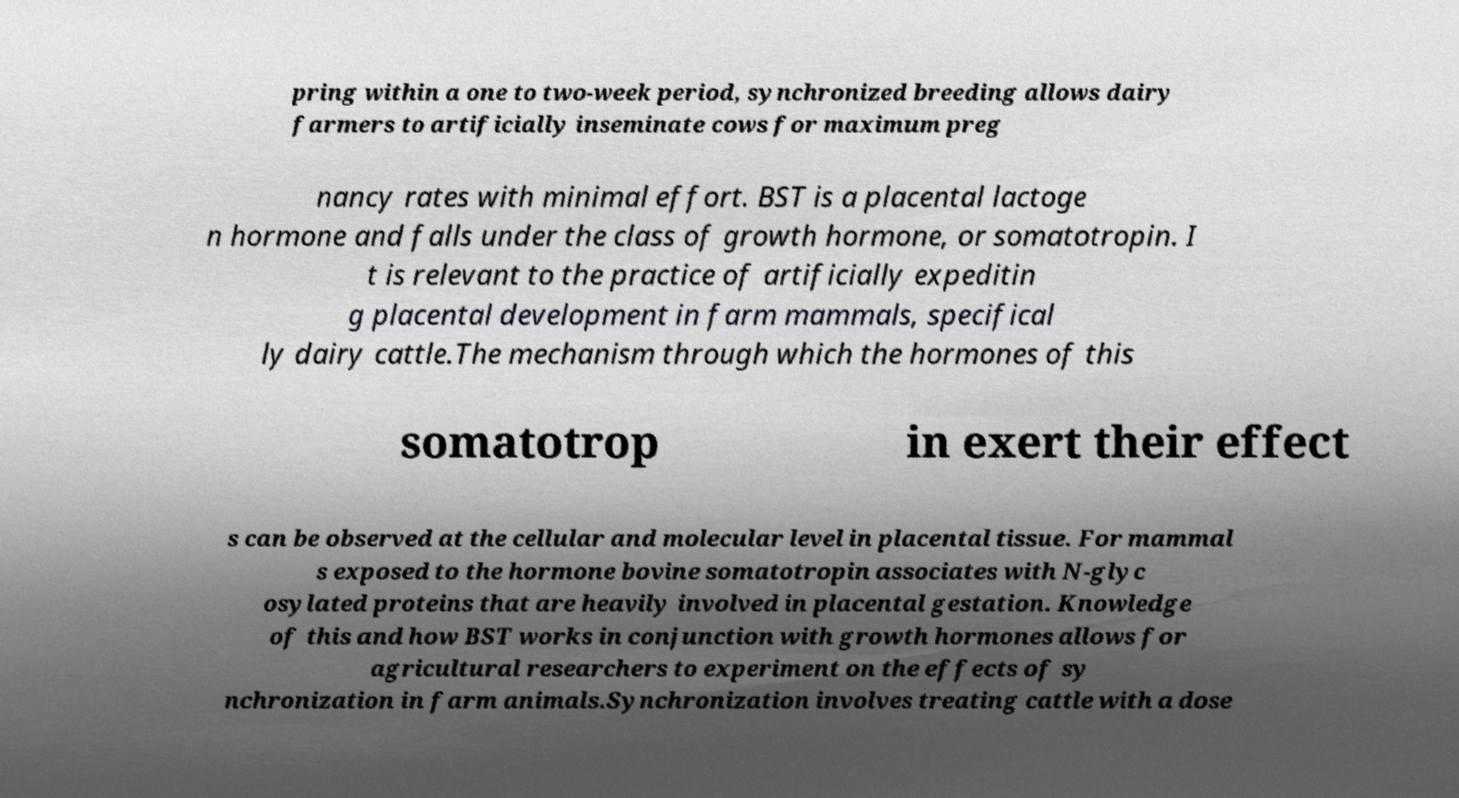Can you read and provide the text displayed in the image?This photo seems to have some interesting text. Can you extract and type it out for me? pring within a one to two-week period, synchronized breeding allows dairy farmers to artificially inseminate cows for maximum preg nancy rates with minimal effort. BST is a placental lactoge n hormone and falls under the class of growth hormone, or somatotropin. I t is relevant to the practice of artificially expeditin g placental development in farm mammals, specifical ly dairy cattle.The mechanism through which the hormones of this somatotrop in exert their effect s can be observed at the cellular and molecular level in placental tissue. For mammal s exposed to the hormone bovine somatotropin associates with N-glyc osylated proteins that are heavily involved in placental gestation. Knowledge of this and how BST works in conjunction with growth hormones allows for agricultural researchers to experiment on the effects of sy nchronization in farm animals.Synchronization involves treating cattle with a dose 